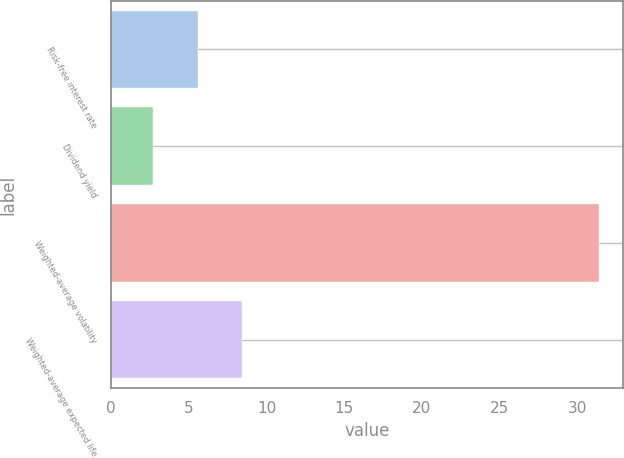<chart> <loc_0><loc_0><loc_500><loc_500><bar_chart><fcel>Risk-free interest rate<fcel>Dividend yield<fcel>Weighted-average volatility<fcel>Weighted-average expected life<nl><fcel>5.57<fcel>2.7<fcel>31.4<fcel>8.44<nl></chart> 